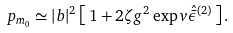Convert formula to latex. <formula><loc_0><loc_0><loc_500><loc_500>p _ { m _ { 0 } } \simeq | b | ^ { 2 } \left [ \, 1 + 2 \zeta g ^ { 2 } \exp v { \hat { \bar { \epsilon } } ^ { ( 2 ) } } \, \right ] .</formula> 